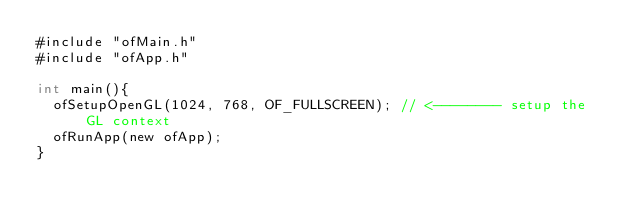<code> <loc_0><loc_0><loc_500><loc_500><_ObjectiveC_>#include "ofMain.h"
#include "ofApp.h"

int main(){
	ofSetupOpenGL(1024, 768, OF_FULLSCREEN); // <-------- setup the GL context
	ofRunApp(new ofApp);
}
</code> 